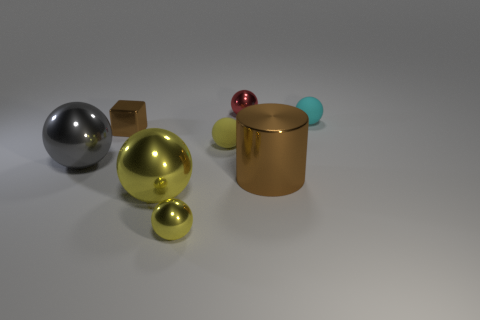How many shiny objects have the same color as the block?
Provide a succinct answer. 1. Are there any other things that have the same color as the metal cylinder?
Your answer should be very brief. Yes. What number of tiny things are behind the yellow sphere that is behind the brown metal cylinder?
Provide a short and direct response. 3. Are there more big gray metallic balls in front of the cyan object than tiny red rubber cylinders?
Ensure brevity in your answer.  Yes. How big is the metal object that is both behind the tiny yellow matte ball and on the right side of the tiny brown thing?
Keep it short and to the point. Small. What is the shape of the small metal thing that is in front of the small cyan thing and right of the small brown shiny block?
Give a very brief answer. Sphere. Is there a tiny ball that is in front of the brown thing to the left of the brown thing that is on the right side of the tiny red metallic thing?
Keep it short and to the point. Yes. How many things are tiny matte spheres to the left of the small cyan matte sphere or shiny objects in front of the tiny brown block?
Offer a terse response. 5. Are the tiny yellow thing left of the yellow rubber thing and the large cylinder made of the same material?
Keep it short and to the point. Yes. There is a sphere that is both left of the tiny yellow matte object and behind the cylinder; what is its material?
Your answer should be very brief. Metal. 